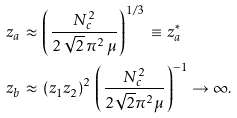Convert formula to latex. <formula><loc_0><loc_0><loc_500><loc_500>& z _ { a } \, \approx \, \left ( \frac { N _ { c } ^ { 2 } } { 2 \, \sqrt { 2 } \, \pi ^ { 2 } \, \mu } \right ) ^ { 1 / 3 } \, \equiv \, z _ { a } ^ { * } \\ & z _ { b } \, \approx \, ( z _ { 1 } z _ { 2 } ) ^ { 2 } \, \left ( \frac { N _ { c } ^ { 2 } } { 2 \sqrt { 2 } \pi ^ { 2 } \mu } \right ) ^ { - 1 } \rightarrow \infty .</formula> 